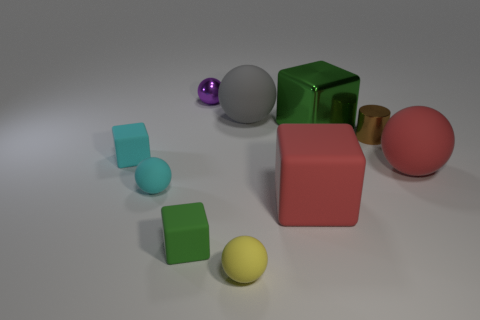What could be the relative sizes of the objects in comparison to each other? The green block in the center appears to be the largest object, followed by the pink sphere. The metallic cylinder and the yellow ball are smaller, whereas the tiny purple ball is the smallest visible object. The two cyan-colored cubes are of a medium size, larger than the small spheres but smaller than the green block and pink sphere. 